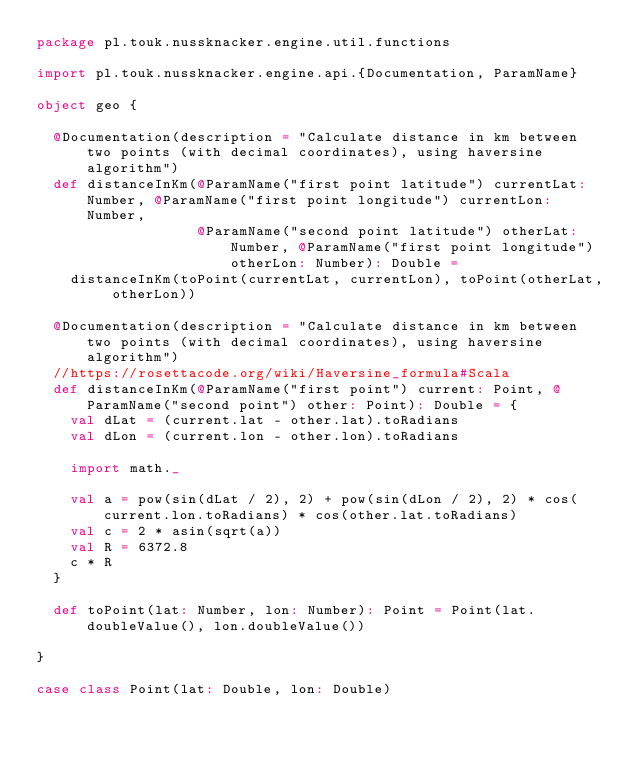Convert code to text. <code><loc_0><loc_0><loc_500><loc_500><_Scala_>package pl.touk.nussknacker.engine.util.functions

import pl.touk.nussknacker.engine.api.{Documentation, ParamName}

object geo {

  @Documentation(description = "Calculate distance in km between two points (with decimal coordinates), using haversine algorithm")
  def distanceInKm(@ParamName("first point latitude") currentLat: Number, @ParamName("first point longitude") currentLon: Number,
                   @ParamName("second point latitude") otherLat: Number, @ParamName("first point longitude") otherLon: Number): Double =
    distanceInKm(toPoint(currentLat, currentLon), toPoint(otherLat, otherLon))

  @Documentation(description = "Calculate distance in km between two points (with decimal coordinates), using haversine algorithm")
  //https://rosettacode.org/wiki/Haversine_formula#Scala
  def distanceInKm(@ParamName("first point") current: Point, @ParamName("second point") other: Point): Double = {
    val dLat = (current.lat - other.lat).toRadians
    val dLon = (current.lon - other.lon).toRadians

    import math._

    val a = pow(sin(dLat / 2), 2) + pow(sin(dLon / 2), 2) * cos(current.lon.toRadians) * cos(other.lat.toRadians)
    val c = 2 * asin(sqrt(a))
    val R = 6372.8
    c * R
  }

  def toPoint(lat: Number, lon: Number): Point = Point(lat.doubleValue(), lon.doubleValue())

}

case class Point(lat: Double, lon: Double)
</code> 